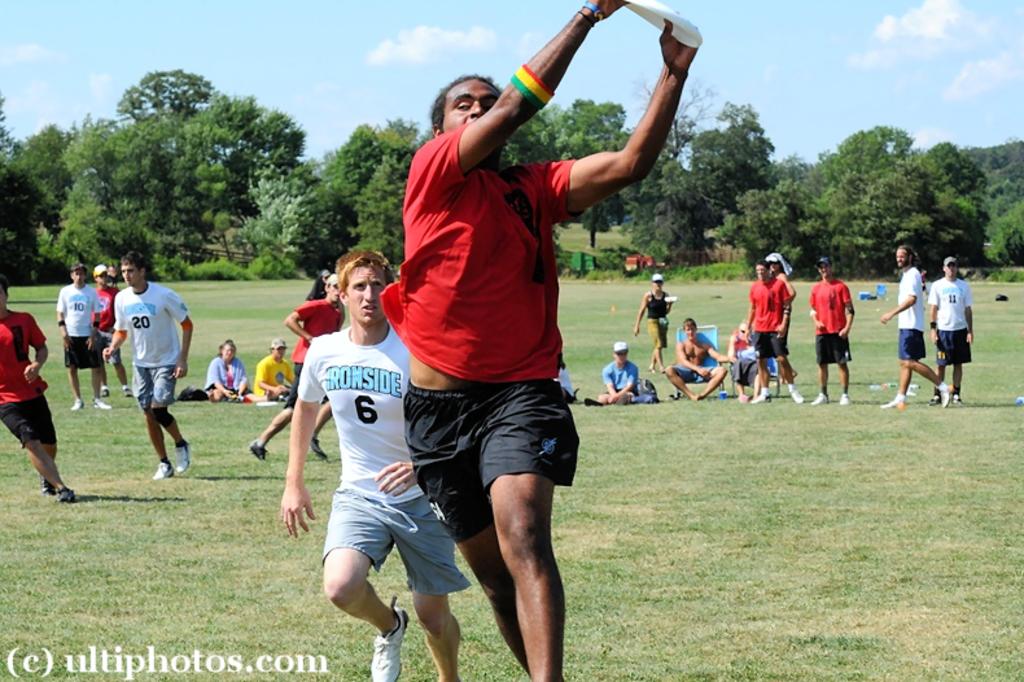What number is on the white t-shirt?
Make the answer very short. 6. 